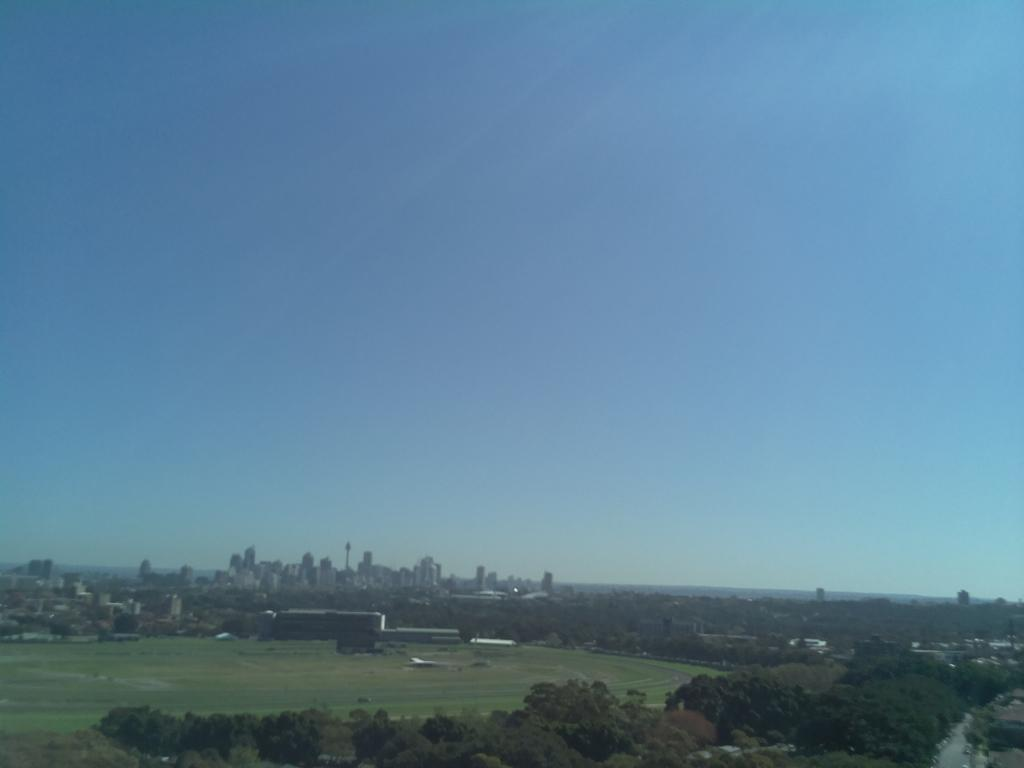What type of vegetation can be seen in the image? There are trees and grass in the image. What structures are visible in the image? There are buildings in the image. What type of crib is visible in the image? There is no crib present in the image. What type of argument is taking place in the image? There is no argument present in the image. 